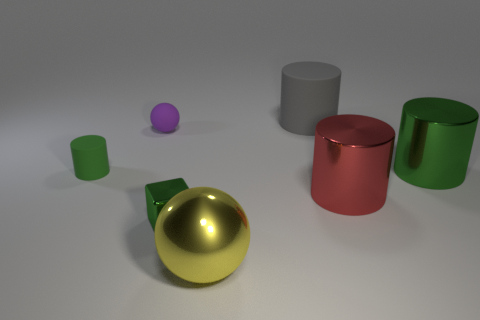Can you describe the texture of the objects in the scene? Certainly, the objects appear to have a variety of textures: the golden ball has a polished, reflective surface; the green objects have a matte, slightly rough texture; and the purple sphere has a smooth but non-reflective surface, suggesting a matte finish.  How do these textures contribute to the overall composition of the image? The interplay of textures creates visual interest and contrast. The reflectiveness of the gold sphere draws the eye and adds a focal point, while the matte finished objects provide subdued elements that balance the composition. 